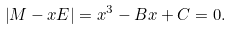<formula> <loc_0><loc_0><loc_500><loc_500>\left | M - x E \right | = x ^ { 3 } - B x + C = 0 .</formula> 